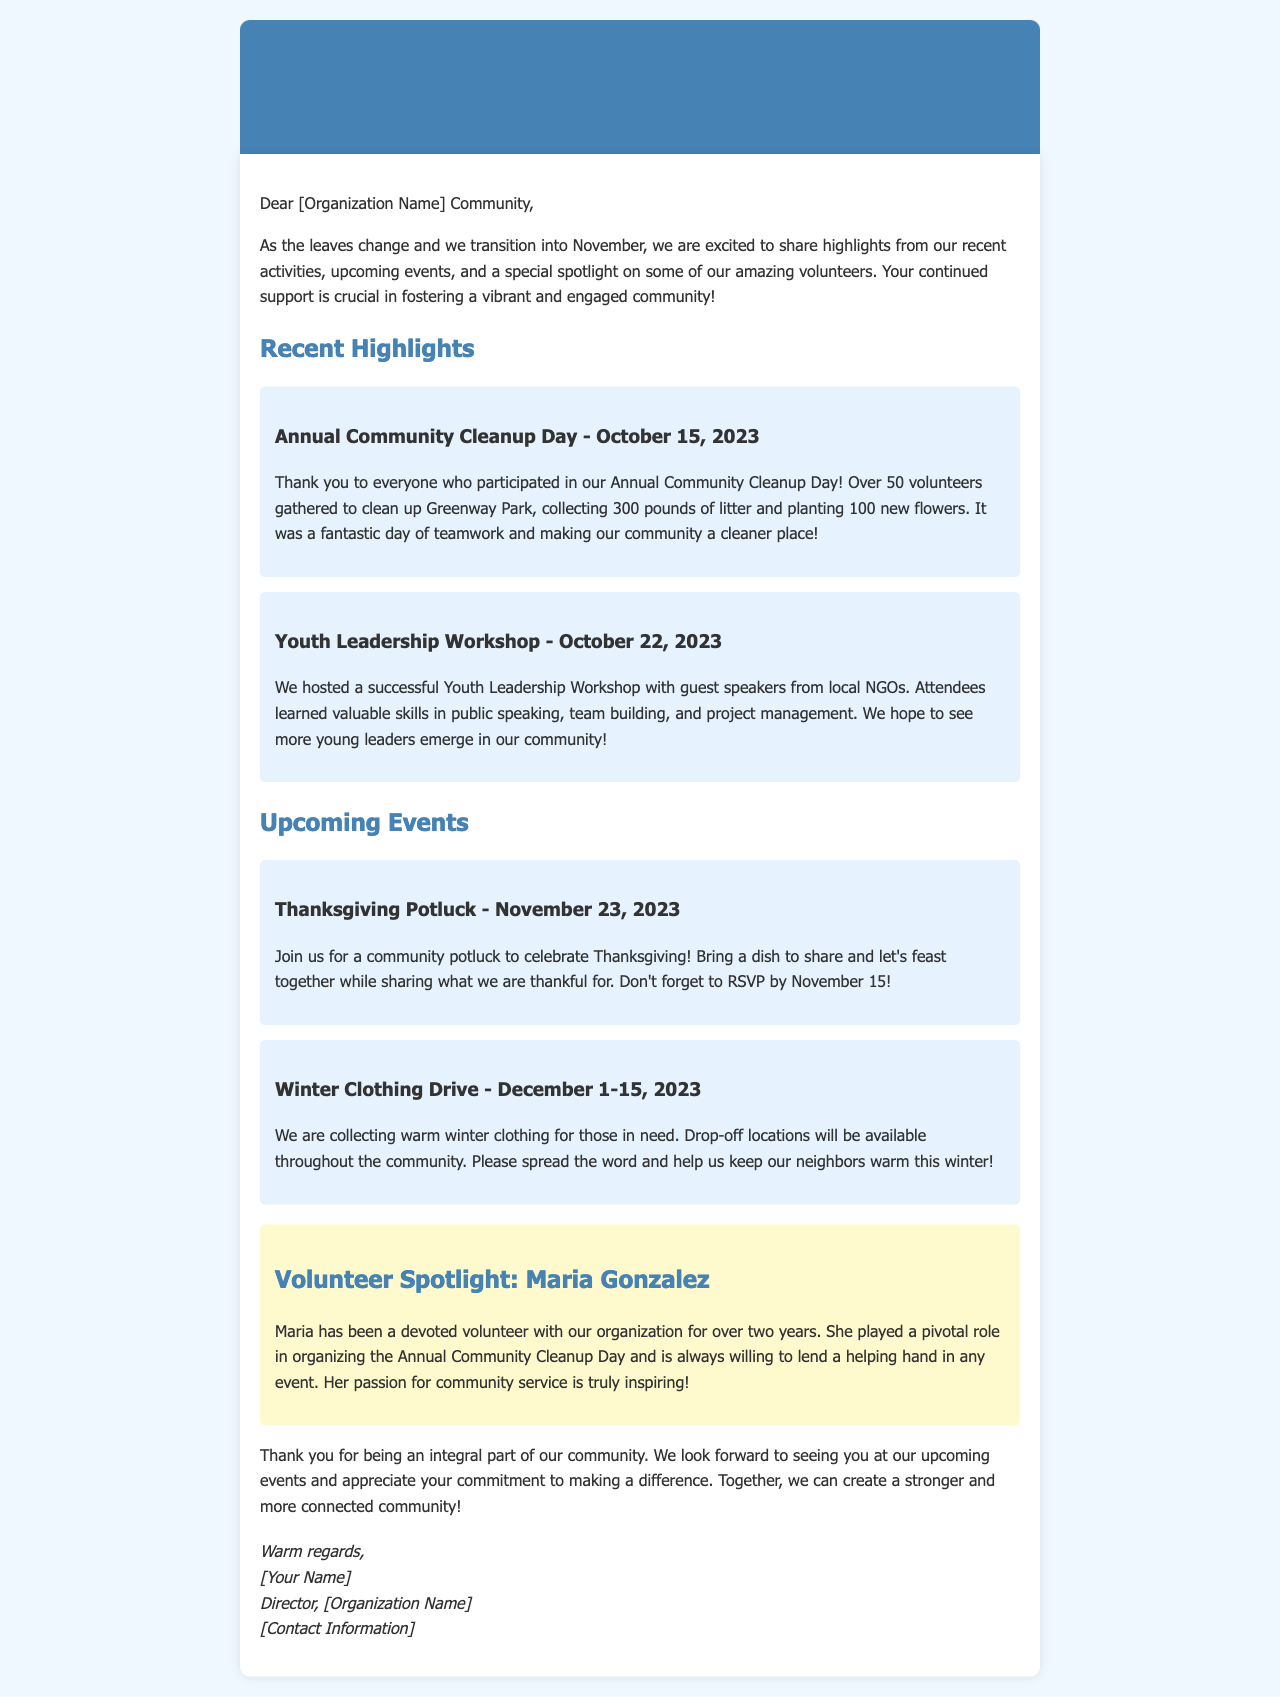What was the date of the Annual Community Cleanup Day? The date mentioned for the Annual Community Cleanup Day is October 15, 2023.
Answer: October 15, 2023 How many pounds of litter were collected during the cleanup? The document states that 300 pounds of litter were collected during the cleanup.
Answer: 300 pounds What event is scheduled for November 23, 2023? The document mentions a Thanksgiving Potluck scheduled for November 23, 2023.
Answer: Thanksgiving Potluck Who is featured in the Volunteer Spotlight? The document highlights Maria Gonzalez as the featured volunteer.
Answer: Maria Gonzalez What skills did attendees learn in the Youth Leadership Workshop? The attendees learned public speaking, team building, and project management skills at the Youth Leadership Workshop.
Answer: Public speaking, team building, project management What is the purpose of the Winter Clothing Drive? The purpose of the Winter Clothing Drive is to collect warm winter clothing for those in need.
Answer: To collect warm winter clothing How long has Maria Gonzalez been volunteering with the organization? According to the document, Maria Gonzalez has been a devoted volunteer for over two years.
Answer: Over two years What is required to attend the Thanksgiving Potluck? Participants are required to bring a dish to share and RSVP by November 15.
Answer: Bring a dish and RSVP by November 15 